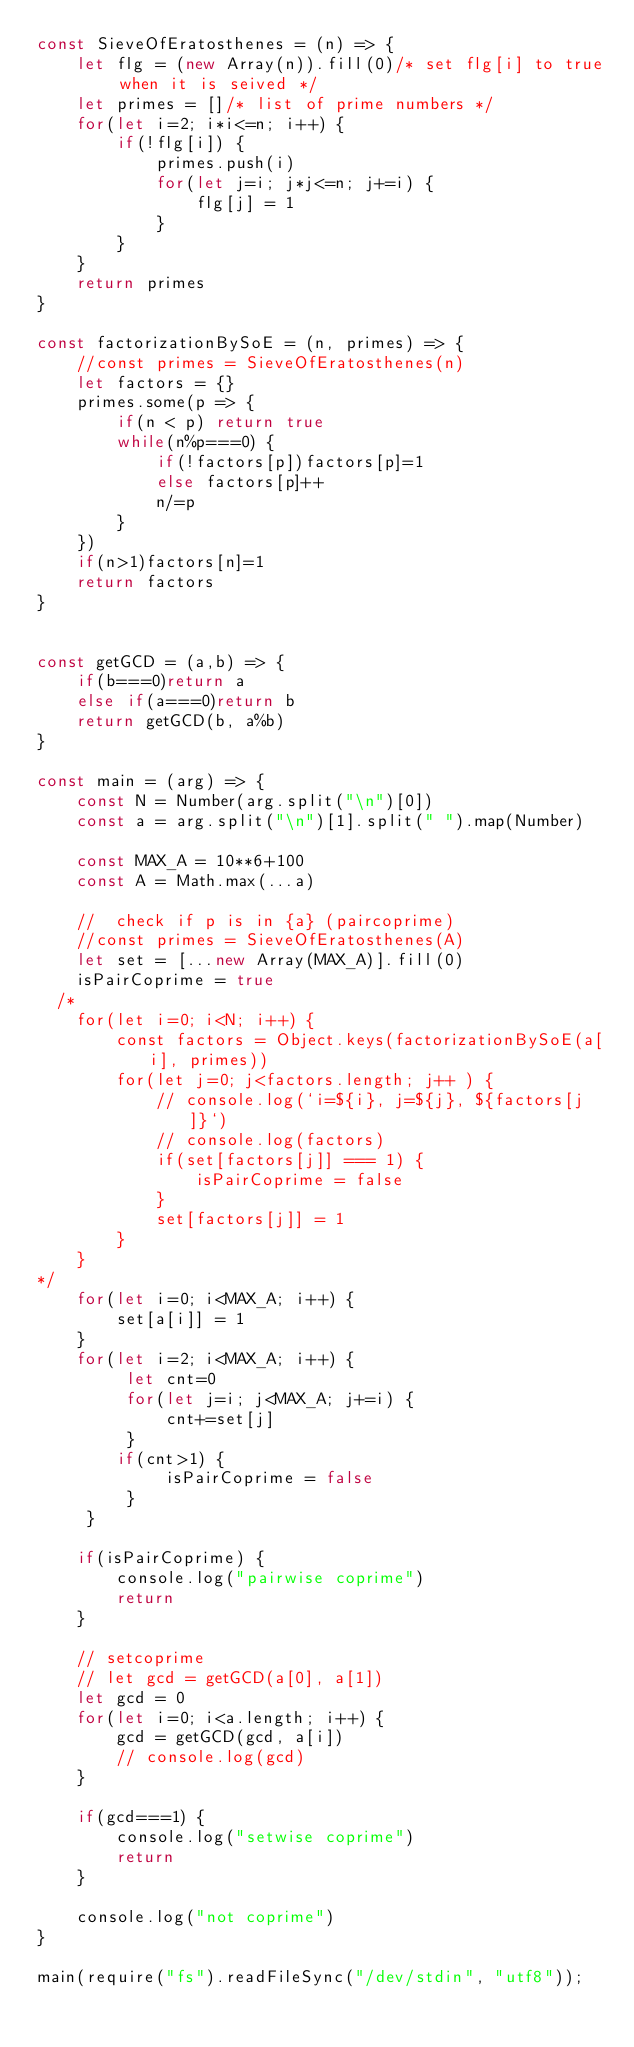<code> <loc_0><loc_0><loc_500><loc_500><_JavaScript_>const SieveOfEratosthenes = (n) => {
    let flg = (new Array(n)).fill(0)/* set flg[i] to true when it is seived */
    let primes = []/* list of prime numbers */
    for(let i=2; i*i<=n; i++) {
        if(!flg[i]) {
            primes.push(i)
            for(let j=i; j*j<=n; j+=i) {
                flg[j] = 1
            }
        }
    }
    return primes
}

const factorizationBySoE = (n, primes) => {
    //const primes = SieveOfEratosthenes(n)
    let factors = {}
    primes.some(p => {
        if(n < p) return true
        while(n%p===0) {
            if(!factors[p])factors[p]=1
            else factors[p]++
            n/=p
        }
    })
    if(n>1)factors[n]=1
    return factors
}


const getGCD = (a,b) => {
    if(b===0)return a
    else if(a===0)return b
    return getGCD(b, a%b)
}

const main = (arg) => {
    const N = Number(arg.split("\n")[0])
    const a = arg.split("\n")[1].split(" ").map(Number)
    
    const MAX_A = 10**6+100
    const A = Math.max(...a)
    
    //  check if p is in {a} (paircoprime)
    //const primes = SieveOfEratosthenes(A)
    let set = [...new Array(MAX_A)].fill(0)
    isPairCoprime = true
  /*
    for(let i=0; i<N; i++) {
        const factors = Object.keys(factorizationBySoE(a[i], primes))
        for(let j=0; j<factors.length; j++ ) {
            // console.log(`i=${i}, j=${j}, ${factors[j]}`)
            // console.log(factors)
            if(set[factors[j]] === 1) {
                isPairCoprime = false
            }
            set[factors[j]] = 1
        }
    }
*/
    for(let i=0; i<MAX_A; i++) {
        set[a[i]] = 1
    }
    for(let i=2; i<MAX_A; i++) {
         let cnt=0
         for(let j=i; j<MAX_A; j+=i) {
             cnt+=set[j]
         }
        if(cnt>1) {
             isPairCoprime = false
         }
     }
    
    if(isPairCoprime) {
        console.log("pairwise coprime")
        return
    }
    
    // setcoprime
    // let gcd = getGCD(a[0], a[1])
    let gcd = 0
    for(let i=0; i<a.length; i++) {
        gcd = getGCD(gcd, a[i])
        // console.log(gcd)
    }
    
    if(gcd===1) {
        console.log("setwise coprime")
        return
    }
    
    console.log("not coprime")
}

main(require("fs").readFileSync("/dev/stdin", "utf8"));</code> 